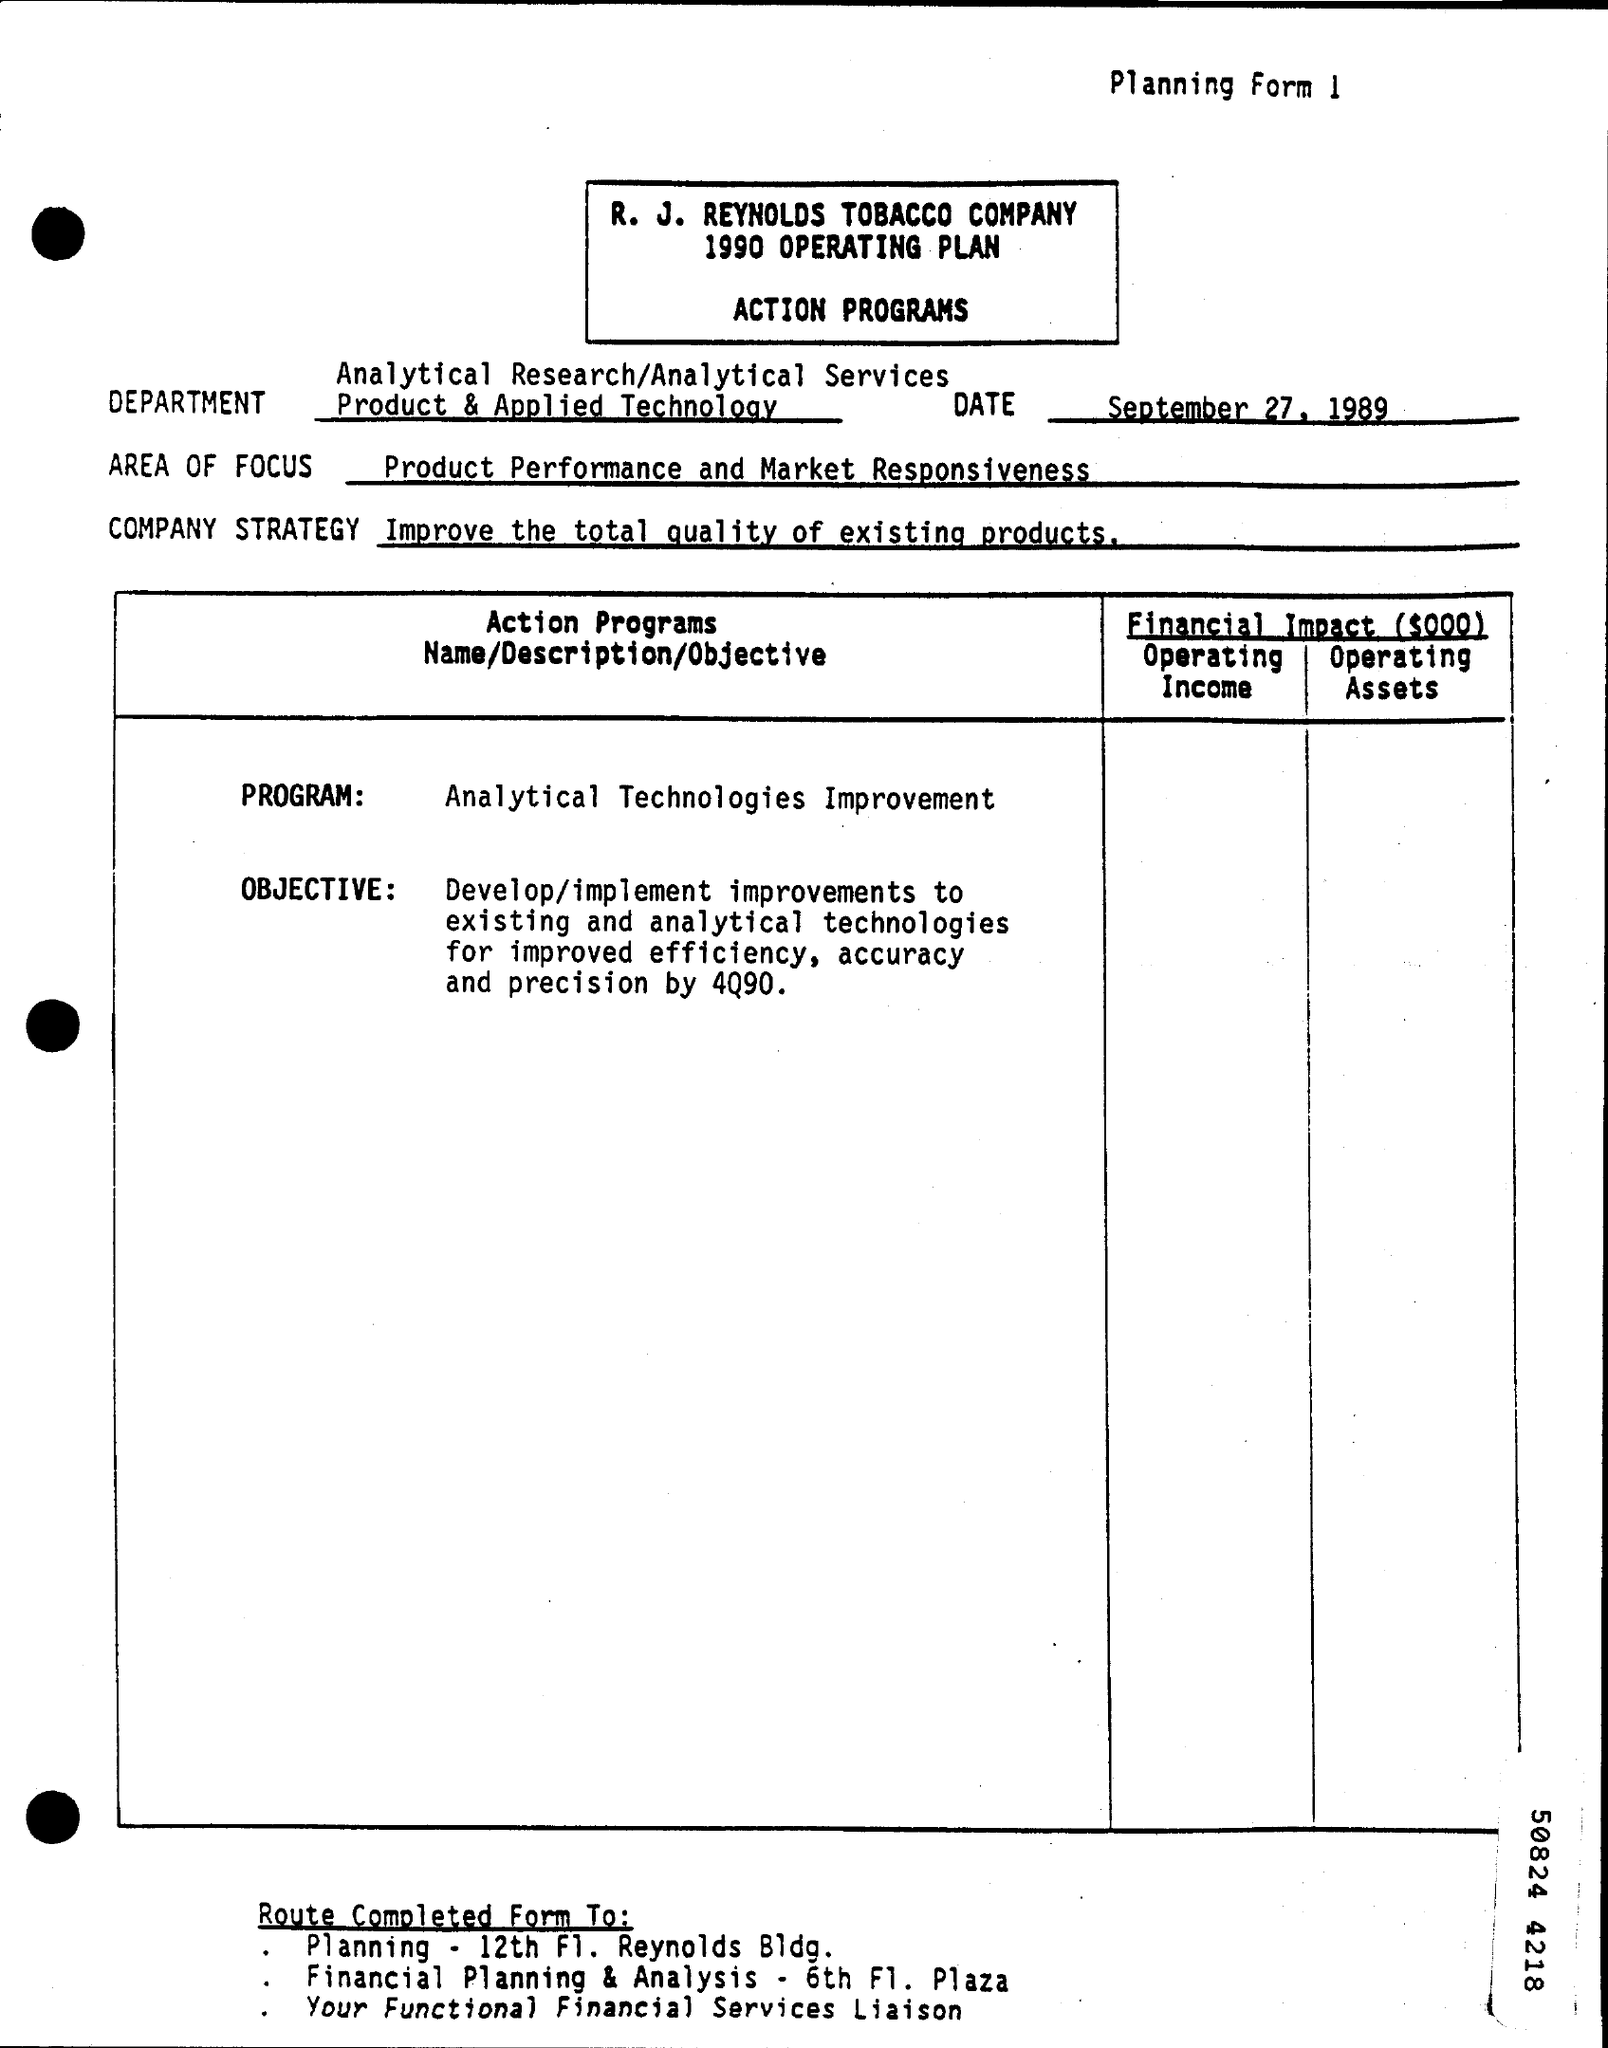Highlight a few significant elements in this photo. The company's strategy is focused on improving the overall quality of our existing products in order to provide our customers with the best possible experience. The Program Field contains the text 'Analytical Technologies Improvement.'  The phrase 'What is the Number for Planning Form ? 1..' is a question asking for information about a specific type of form and its purpose. The memorandum is dated September 27, 1989. The focus area is concerned with the product's performance and market responsiveness. 